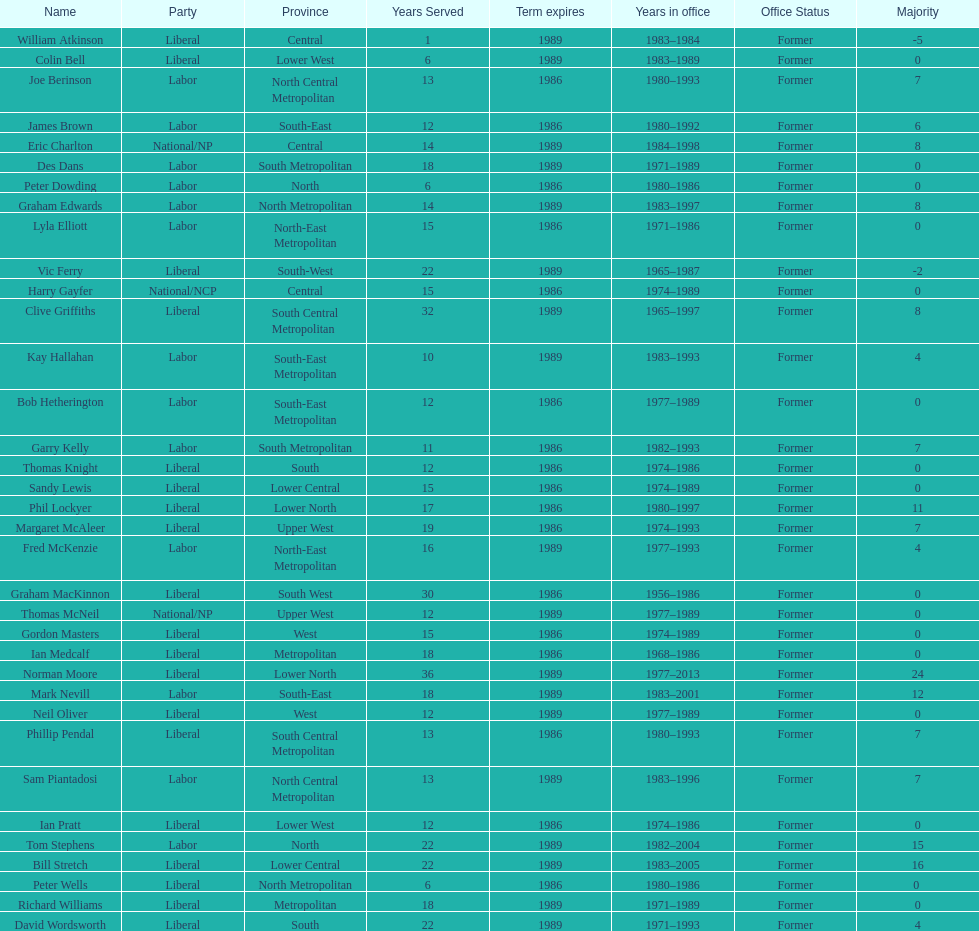Hame the last member listed whose last name begins with "p". Ian Pratt. 